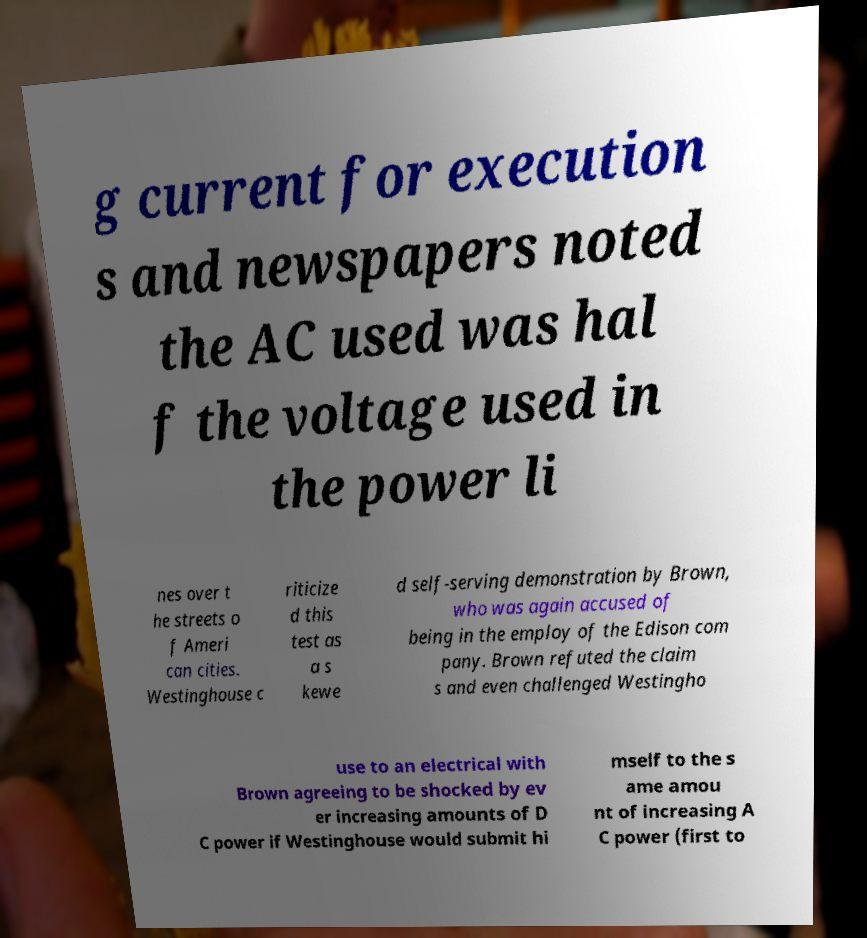Can you read and provide the text displayed in the image?This photo seems to have some interesting text. Can you extract and type it out for me? g current for execution s and newspapers noted the AC used was hal f the voltage used in the power li nes over t he streets o f Ameri can cities. Westinghouse c riticize d this test as a s kewe d self-serving demonstration by Brown, who was again accused of being in the employ of the Edison com pany. Brown refuted the claim s and even challenged Westingho use to an electrical with Brown agreeing to be shocked by ev er increasing amounts of D C power if Westinghouse would submit hi mself to the s ame amou nt of increasing A C power (first to 